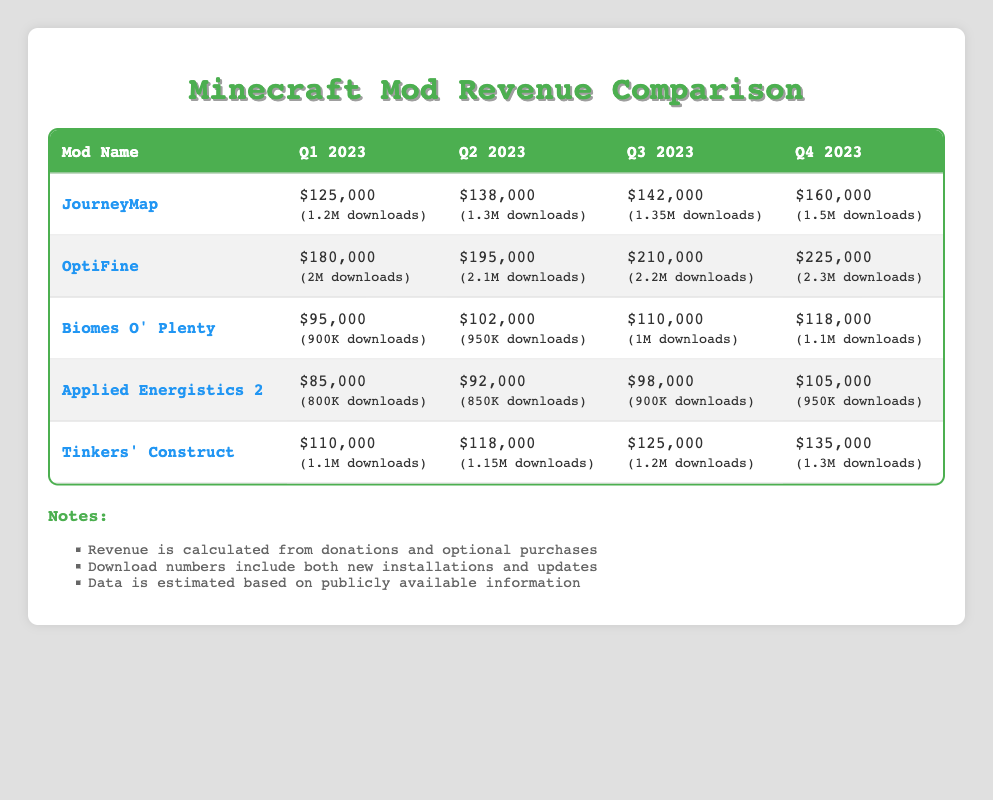What was the revenue for JourneyMap in Q4 2023? The table shows that the revenue for JourneyMap in Q4 2023 is $160,000.
Answer: $160,000 Which mod had the highest revenue in Q2 2023? The revenue for each mod in Q2 2023 is: JourneyMap - $138,000, OptiFine - $195,000, Biomes O' Plenty - $102,000, Applied Energistics 2 - $92,000, and Tinkers' Construct - $118,000. OptiFine has the highest revenue of $195,000.
Answer: OptiFine What is the total revenue from all mods in Q1 2023? The revenues for Q1 2023 are: JourneyMap - $125,000, OptiFine - $180,000, Biomes O' Plenty - $95,000, Applied Energistics 2 - $85,000, and Tinkers' Construct - $110,000. Summing these gives: 125,000 + 180,000 + 95,000 + 85,000 + 110,000 = 595,000.
Answer: $595,000 Is the revenue from Tinkers' Construct consistently increasing over the quarters? The revenues for Tinkers' Construct are: Q1 - $110,000, Q2 - $118,000, Q3 - $125,000, Q4 - $135,000. Since each revenue figure is greater than the previous one, it shows a consistent increase.
Answer: Yes What is the average revenue for OptiFine over the four quarters? The revenues for OptiFine over the four quarters are: Q1 - $180,000, Q2 - $195,000, Q3 - $210,000, Q4 - $225,000. The sum is 180,000 + 195,000 + 210,000 + 225,000 = 810,000; dividing by 4 gives an average of 810,000 / 4 = 202,500.
Answer: $202,500 Which mod had the lowest revenue increase from Q3 to Q4 2023? The revenue increases from Q3 to Q4 for the mods are: JourneyMap: $160,000 - $142,000 = $18,000, OptiFine: $225,000 - $210,000 = $15,000, Biomes O' Plenty: $118,000 - $110,000 = $8,000, Applied Energistics 2: $105,000 - $98,000 = $7,000, Tinkers' Construct: $135,000 - $125,000 = $10,000. The lowest increase is $7,000 for Applied Energistics 2.
Answer: Applied Energistics 2 In which quarter did Biomes O' Plenty have its maximum revenue, and what was that amount? The revenues for Biomes O' Plenty are: Q1 - $95,000, Q2 - $102,000, Q3 - $110,000, and Q4 - $118,000. The maximum revenue occurs in Q4 with $118,000.
Answer: Q4 2023, $118,000 How much more revenue did OptiFine generate in Q4 compared to JourneyMap in the same quarter? The revenue for OptiFine in Q4 is $225,000, and for JourneyMap, it is $160,000. The difference is $225,000 - $160,000 = $65,000.
Answer: $65,000 